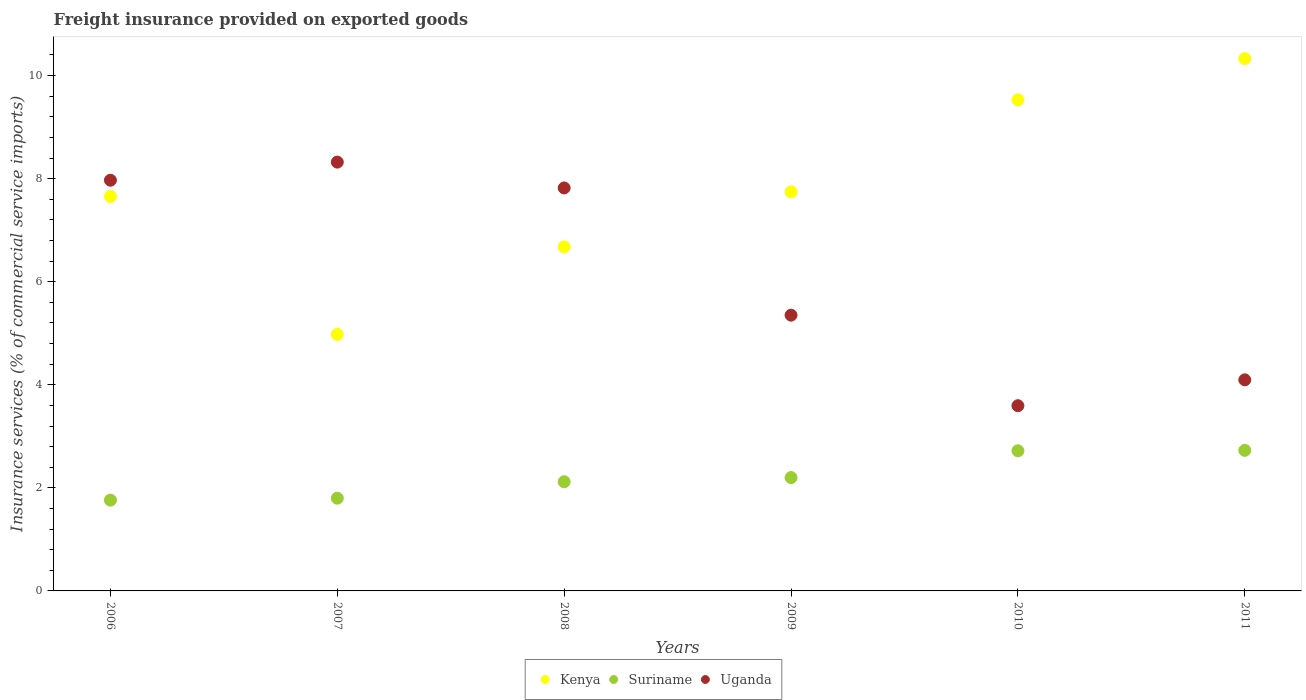What is the freight insurance provided on exported goods in Suriname in 2009?
Provide a short and direct response. 2.2. Across all years, what is the maximum freight insurance provided on exported goods in Uganda?
Keep it short and to the point. 8.32. Across all years, what is the minimum freight insurance provided on exported goods in Uganda?
Your answer should be very brief. 3.59. In which year was the freight insurance provided on exported goods in Kenya maximum?
Offer a terse response. 2011. In which year was the freight insurance provided on exported goods in Kenya minimum?
Make the answer very short. 2007. What is the total freight insurance provided on exported goods in Uganda in the graph?
Offer a very short reply. 37.15. What is the difference between the freight insurance provided on exported goods in Uganda in 2008 and that in 2011?
Keep it short and to the point. 3.72. What is the difference between the freight insurance provided on exported goods in Kenya in 2009 and the freight insurance provided on exported goods in Uganda in 2010?
Your answer should be compact. 4.15. What is the average freight insurance provided on exported goods in Suriname per year?
Your answer should be very brief. 2.22. In the year 2011, what is the difference between the freight insurance provided on exported goods in Kenya and freight insurance provided on exported goods in Suriname?
Provide a succinct answer. 7.6. In how many years, is the freight insurance provided on exported goods in Kenya greater than 3.2 %?
Provide a short and direct response. 6. What is the ratio of the freight insurance provided on exported goods in Uganda in 2006 to that in 2007?
Offer a very short reply. 0.96. Is the difference between the freight insurance provided on exported goods in Kenya in 2007 and 2011 greater than the difference between the freight insurance provided on exported goods in Suriname in 2007 and 2011?
Offer a very short reply. No. What is the difference between the highest and the second highest freight insurance provided on exported goods in Suriname?
Your answer should be very brief. 0.01. What is the difference between the highest and the lowest freight insurance provided on exported goods in Kenya?
Your answer should be compact. 5.35. Does the freight insurance provided on exported goods in Kenya monotonically increase over the years?
Offer a terse response. No. Is the freight insurance provided on exported goods in Kenya strictly greater than the freight insurance provided on exported goods in Uganda over the years?
Your answer should be compact. No. How many dotlines are there?
Your response must be concise. 3. How many years are there in the graph?
Ensure brevity in your answer.  6. Does the graph contain any zero values?
Your response must be concise. No. Does the graph contain grids?
Keep it short and to the point. No. Where does the legend appear in the graph?
Provide a succinct answer. Bottom center. How many legend labels are there?
Give a very brief answer. 3. What is the title of the graph?
Keep it short and to the point. Freight insurance provided on exported goods. What is the label or title of the X-axis?
Offer a very short reply. Years. What is the label or title of the Y-axis?
Keep it short and to the point. Insurance services (% of commercial service imports). What is the Insurance services (% of commercial service imports) in Kenya in 2006?
Provide a short and direct response. 7.65. What is the Insurance services (% of commercial service imports) of Suriname in 2006?
Provide a short and direct response. 1.76. What is the Insurance services (% of commercial service imports) of Uganda in 2006?
Your answer should be very brief. 7.97. What is the Insurance services (% of commercial service imports) of Kenya in 2007?
Offer a very short reply. 4.98. What is the Insurance services (% of commercial service imports) in Suriname in 2007?
Provide a short and direct response. 1.8. What is the Insurance services (% of commercial service imports) of Uganda in 2007?
Ensure brevity in your answer.  8.32. What is the Insurance services (% of commercial service imports) of Kenya in 2008?
Offer a terse response. 6.68. What is the Insurance services (% of commercial service imports) in Suriname in 2008?
Offer a very short reply. 2.12. What is the Insurance services (% of commercial service imports) of Uganda in 2008?
Give a very brief answer. 7.82. What is the Insurance services (% of commercial service imports) of Kenya in 2009?
Offer a very short reply. 7.74. What is the Insurance services (% of commercial service imports) in Suriname in 2009?
Your answer should be very brief. 2.2. What is the Insurance services (% of commercial service imports) of Uganda in 2009?
Ensure brevity in your answer.  5.35. What is the Insurance services (% of commercial service imports) in Kenya in 2010?
Provide a short and direct response. 9.53. What is the Insurance services (% of commercial service imports) in Suriname in 2010?
Your answer should be very brief. 2.72. What is the Insurance services (% of commercial service imports) in Uganda in 2010?
Provide a succinct answer. 3.59. What is the Insurance services (% of commercial service imports) of Kenya in 2011?
Your answer should be very brief. 10.33. What is the Insurance services (% of commercial service imports) of Suriname in 2011?
Keep it short and to the point. 2.73. What is the Insurance services (% of commercial service imports) in Uganda in 2011?
Offer a terse response. 4.1. Across all years, what is the maximum Insurance services (% of commercial service imports) of Kenya?
Offer a very short reply. 10.33. Across all years, what is the maximum Insurance services (% of commercial service imports) of Suriname?
Give a very brief answer. 2.73. Across all years, what is the maximum Insurance services (% of commercial service imports) in Uganda?
Provide a succinct answer. 8.32. Across all years, what is the minimum Insurance services (% of commercial service imports) in Kenya?
Ensure brevity in your answer.  4.98. Across all years, what is the minimum Insurance services (% of commercial service imports) of Suriname?
Give a very brief answer. 1.76. Across all years, what is the minimum Insurance services (% of commercial service imports) in Uganda?
Your response must be concise. 3.59. What is the total Insurance services (% of commercial service imports) in Kenya in the graph?
Your response must be concise. 46.91. What is the total Insurance services (% of commercial service imports) of Suriname in the graph?
Offer a very short reply. 13.33. What is the total Insurance services (% of commercial service imports) of Uganda in the graph?
Provide a succinct answer. 37.15. What is the difference between the Insurance services (% of commercial service imports) of Kenya in 2006 and that in 2007?
Provide a succinct answer. 2.68. What is the difference between the Insurance services (% of commercial service imports) of Suriname in 2006 and that in 2007?
Your answer should be very brief. -0.04. What is the difference between the Insurance services (% of commercial service imports) in Uganda in 2006 and that in 2007?
Ensure brevity in your answer.  -0.35. What is the difference between the Insurance services (% of commercial service imports) in Kenya in 2006 and that in 2008?
Keep it short and to the point. 0.98. What is the difference between the Insurance services (% of commercial service imports) in Suriname in 2006 and that in 2008?
Provide a succinct answer. -0.36. What is the difference between the Insurance services (% of commercial service imports) in Uganda in 2006 and that in 2008?
Make the answer very short. 0.15. What is the difference between the Insurance services (% of commercial service imports) in Kenya in 2006 and that in 2009?
Keep it short and to the point. -0.09. What is the difference between the Insurance services (% of commercial service imports) in Suriname in 2006 and that in 2009?
Make the answer very short. -0.44. What is the difference between the Insurance services (% of commercial service imports) of Uganda in 2006 and that in 2009?
Your response must be concise. 2.62. What is the difference between the Insurance services (% of commercial service imports) in Kenya in 2006 and that in 2010?
Make the answer very short. -1.88. What is the difference between the Insurance services (% of commercial service imports) in Suriname in 2006 and that in 2010?
Give a very brief answer. -0.96. What is the difference between the Insurance services (% of commercial service imports) of Uganda in 2006 and that in 2010?
Provide a short and direct response. 4.38. What is the difference between the Insurance services (% of commercial service imports) of Kenya in 2006 and that in 2011?
Make the answer very short. -2.67. What is the difference between the Insurance services (% of commercial service imports) in Suriname in 2006 and that in 2011?
Keep it short and to the point. -0.97. What is the difference between the Insurance services (% of commercial service imports) of Uganda in 2006 and that in 2011?
Your response must be concise. 3.87. What is the difference between the Insurance services (% of commercial service imports) of Kenya in 2007 and that in 2008?
Make the answer very short. -1.7. What is the difference between the Insurance services (% of commercial service imports) of Suriname in 2007 and that in 2008?
Keep it short and to the point. -0.32. What is the difference between the Insurance services (% of commercial service imports) in Uganda in 2007 and that in 2008?
Offer a terse response. 0.5. What is the difference between the Insurance services (% of commercial service imports) in Kenya in 2007 and that in 2009?
Make the answer very short. -2.77. What is the difference between the Insurance services (% of commercial service imports) in Suriname in 2007 and that in 2009?
Provide a succinct answer. -0.4. What is the difference between the Insurance services (% of commercial service imports) of Uganda in 2007 and that in 2009?
Provide a short and direct response. 2.97. What is the difference between the Insurance services (% of commercial service imports) of Kenya in 2007 and that in 2010?
Provide a succinct answer. -4.55. What is the difference between the Insurance services (% of commercial service imports) of Suriname in 2007 and that in 2010?
Give a very brief answer. -0.92. What is the difference between the Insurance services (% of commercial service imports) of Uganda in 2007 and that in 2010?
Provide a succinct answer. 4.73. What is the difference between the Insurance services (% of commercial service imports) in Kenya in 2007 and that in 2011?
Your response must be concise. -5.35. What is the difference between the Insurance services (% of commercial service imports) in Suriname in 2007 and that in 2011?
Give a very brief answer. -0.93. What is the difference between the Insurance services (% of commercial service imports) of Uganda in 2007 and that in 2011?
Make the answer very short. 4.22. What is the difference between the Insurance services (% of commercial service imports) in Kenya in 2008 and that in 2009?
Offer a terse response. -1.07. What is the difference between the Insurance services (% of commercial service imports) in Suriname in 2008 and that in 2009?
Provide a short and direct response. -0.08. What is the difference between the Insurance services (% of commercial service imports) in Uganda in 2008 and that in 2009?
Offer a terse response. 2.47. What is the difference between the Insurance services (% of commercial service imports) of Kenya in 2008 and that in 2010?
Provide a succinct answer. -2.85. What is the difference between the Insurance services (% of commercial service imports) of Suriname in 2008 and that in 2010?
Your response must be concise. -0.6. What is the difference between the Insurance services (% of commercial service imports) in Uganda in 2008 and that in 2010?
Provide a succinct answer. 4.23. What is the difference between the Insurance services (% of commercial service imports) of Kenya in 2008 and that in 2011?
Offer a terse response. -3.65. What is the difference between the Insurance services (% of commercial service imports) in Suriname in 2008 and that in 2011?
Provide a short and direct response. -0.61. What is the difference between the Insurance services (% of commercial service imports) of Uganda in 2008 and that in 2011?
Your answer should be compact. 3.72. What is the difference between the Insurance services (% of commercial service imports) in Kenya in 2009 and that in 2010?
Your answer should be very brief. -1.79. What is the difference between the Insurance services (% of commercial service imports) of Suriname in 2009 and that in 2010?
Give a very brief answer. -0.52. What is the difference between the Insurance services (% of commercial service imports) of Uganda in 2009 and that in 2010?
Your answer should be very brief. 1.76. What is the difference between the Insurance services (% of commercial service imports) in Kenya in 2009 and that in 2011?
Provide a succinct answer. -2.58. What is the difference between the Insurance services (% of commercial service imports) in Suriname in 2009 and that in 2011?
Provide a succinct answer. -0.53. What is the difference between the Insurance services (% of commercial service imports) in Uganda in 2009 and that in 2011?
Provide a short and direct response. 1.25. What is the difference between the Insurance services (% of commercial service imports) of Kenya in 2010 and that in 2011?
Provide a succinct answer. -0.8. What is the difference between the Insurance services (% of commercial service imports) in Suriname in 2010 and that in 2011?
Give a very brief answer. -0.01. What is the difference between the Insurance services (% of commercial service imports) of Uganda in 2010 and that in 2011?
Ensure brevity in your answer.  -0.5. What is the difference between the Insurance services (% of commercial service imports) in Kenya in 2006 and the Insurance services (% of commercial service imports) in Suriname in 2007?
Offer a very short reply. 5.85. What is the difference between the Insurance services (% of commercial service imports) of Kenya in 2006 and the Insurance services (% of commercial service imports) of Uganda in 2007?
Your answer should be very brief. -0.67. What is the difference between the Insurance services (% of commercial service imports) of Suriname in 2006 and the Insurance services (% of commercial service imports) of Uganda in 2007?
Provide a short and direct response. -6.56. What is the difference between the Insurance services (% of commercial service imports) in Kenya in 2006 and the Insurance services (% of commercial service imports) in Suriname in 2008?
Keep it short and to the point. 5.54. What is the difference between the Insurance services (% of commercial service imports) in Kenya in 2006 and the Insurance services (% of commercial service imports) in Uganda in 2008?
Your response must be concise. -0.17. What is the difference between the Insurance services (% of commercial service imports) in Suriname in 2006 and the Insurance services (% of commercial service imports) in Uganda in 2008?
Keep it short and to the point. -6.06. What is the difference between the Insurance services (% of commercial service imports) of Kenya in 2006 and the Insurance services (% of commercial service imports) of Suriname in 2009?
Your answer should be very brief. 5.45. What is the difference between the Insurance services (% of commercial service imports) in Kenya in 2006 and the Insurance services (% of commercial service imports) in Uganda in 2009?
Make the answer very short. 2.3. What is the difference between the Insurance services (% of commercial service imports) of Suriname in 2006 and the Insurance services (% of commercial service imports) of Uganda in 2009?
Ensure brevity in your answer.  -3.59. What is the difference between the Insurance services (% of commercial service imports) in Kenya in 2006 and the Insurance services (% of commercial service imports) in Suriname in 2010?
Your answer should be compact. 4.93. What is the difference between the Insurance services (% of commercial service imports) of Kenya in 2006 and the Insurance services (% of commercial service imports) of Uganda in 2010?
Make the answer very short. 4.06. What is the difference between the Insurance services (% of commercial service imports) of Suriname in 2006 and the Insurance services (% of commercial service imports) of Uganda in 2010?
Provide a succinct answer. -1.83. What is the difference between the Insurance services (% of commercial service imports) in Kenya in 2006 and the Insurance services (% of commercial service imports) in Suriname in 2011?
Offer a very short reply. 4.93. What is the difference between the Insurance services (% of commercial service imports) of Kenya in 2006 and the Insurance services (% of commercial service imports) of Uganda in 2011?
Your answer should be very brief. 3.56. What is the difference between the Insurance services (% of commercial service imports) of Suriname in 2006 and the Insurance services (% of commercial service imports) of Uganda in 2011?
Provide a succinct answer. -2.33. What is the difference between the Insurance services (% of commercial service imports) in Kenya in 2007 and the Insurance services (% of commercial service imports) in Suriname in 2008?
Provide a succinct answer. 2.86. What is the difference between the Insurance services (% of commercial service imports) of Kenya in 2007 and the Insurance services (% of commercial service imports) of Uganda in 2008?
Make the answer very short. -2.84. What is the difference between the Insurance services (% of commercial service imports) of Suriname in 2007 and the Insurance services (% of commercial service imports) of Uganda in 2008?
Keep it short and to the point. -6.02. What is the difference between the Insurance services (% of commercial service imports) of Kenya in 2007 and the Insurance services (% of commercial service imports) of Suriname in 2009?
Provide a short and direct response. 2.78. What is the difference between the Insurance services (% of commercial service imports) of Kenya in 2007 and the Insurance services (% of commercial service imports) of Uganda in 2009?
Offer a very short reply. -0.37. What is the difference between the Insurance services (% of commercial service imports) in Suriname in 2007 and the Insurance services (% of commercial service imports) in Uganda in 2009?
Keep it short and to the point. -3.55. What is the difference between the Insurance services (% of commercial service imports) of Kenya in 2007 and the Insurance services (% of commercial service imports) of Suriname in 2010?
Give a very brief answer. 2.26. What is the difference between the Insurance services (% of commercial service imports) in Kenya in 2007 and the Insurance services (% of commercial service imports) in Uganda in 2010?
Ensure brevity in your answer.  1.38. What is the difference between the Insurance services (% of commercial service imports) of Suriname in 2007 and the Insurance services (% of commercial service imports) of Uganda in 2010?
Your answer should be compact. -1.79. What is the difference between the Insurance services (% of commercial service imports) in Kenya in 2007 and the Insurance services (% of commercial service imports) in Suriname in 2011?
Your response must be concise. 2.25. What is the difference between the Insurance services (% of commercial service imports) in Kenya in 2007 and the Insurance services (% of commercial service imports) in Uganda in 2011?
Ensure brevity in your answer.  0.88. What is the difference between the Insurance services (% of commercial service imports) in Suriname in 2007 and the Insurance services (% of commercial service imports) in Uganda in 2011?
Ensure brevity in your answer.  -2.3. What is the difference between the Insurance services (% of commercial service imports) in Kenya in 2008 and the Insurance services (% of commercial service imports) in Suriname in 2009?
Ensure brevity in your answer.  4.48. What is the difference between the Insurance services (% of commercial service imports) in Kenya in 2008 and the Insurance services (% of commercial service imports) in Uganda in 2009?
Your response must be concise. 1.32. What is the difference between the Insurance services (% of commercial service imports) in Suriname in 2008 and the Insurance services (% of commercial service imports) in Uganda in 2009?
Provide a short and direct response. -3.23. What is the difference between the Insurance services (% of commercial service imports) in Kenya in 2008 and the Insurance services (% of commercial service imports) in Suriname in 2010?
Your answer should be very brief. 3.96. What is the difference between the Insurance services (% of commercial service imports) in Kenya in 2008 and the Insurance services (% of commercial service imports) in Uganda in 2010?
Your answer should be compact. 3.08. What is the difference between the Insurance services (% of commercial service imports) of Suriname in 2008 and the Insurance services (% of commercial service imports) of Uganda in 2010?
Your answer should be compact. -1.48. What is the difference between the Insurance services (% of commercial service imports) in Kenya in 2008 and the Insurance services (% of commercial service imports) in Suriname in 2011?
Your answer should be very brief. 3.95. What is the difference between the Insurance services (% of commercial service imports) in Kenya in 2008 and the Insurance services (% of commercial service imports) in Uganda in 2011?
Your answer should be very brief. 2.58. What is the difference between the Insurance services (% of commercial service imports) in Suriname in 2008 and the Insurance services (% of commercial service imports) in Uganda in 2011?
Your answer should be very brief. -1.98. What is the difference between the Insurance services (% of commercial service imports) of Kenya in 2009 and the Insurance services (% of commercial service imports) of Suriname in 2010?
Provide a succinct answer. 5.02. What is the difference between the Insurance services (% of commercial service imports) in Kenya in 2009 and the Insurance services (% of commercial service imports) in Uganda in 2010?
Your answer should be compact. 4.15. What is the difference between the Insurance services (% of commercial service imports) of Suriname in 2009 and the Insurance services (% of commercial service imports) of Uganda in 2010?
Your response must be concise. -1.39. What is the difference between the Insurance services (% of commercial service imports) in Kenya in 2009 and the Insurance services (% of commercial service imports) in Suriname in 2011?
Offer a terse response. 5.02. What is the difference between the Insurance services (% of commercial service imports) in Kenya in 2009 and the Insurance services (% of commercial service imports) in Uganda in 2011?
Provide a succinct answer. 3.65. What is the difference between the Insurance services (% of commercial service imports) in Suriname in 2009 and the Insurance services (% of commercial service imports) in Uganda in 2011?
Your response must be concise. -1.9. What is the difference between the Insurance services (% of commercial service imports) in Kenya in 2010 and the Insurance services (% of commercial service imports) in Suriname in 2011?
Your response must be concise. 6.8. What is the difference between the Insurance services (% of commercial service imports) in Kenya in 2010 and the Insurance services (% of commercial service imports) in Uganda in 2011?
Give a very brief answer. 5.43. What is the difference between the Insurance services (% of commercial service imports) of Suriname in 2010 and the Insurance services (% of commercial service imports) of Uganda in 2011?
Give a very brief answer. -1.38. What is the average Insurance services (% of commercial service imports) of Kenya per year?
Your response must be concise. 7.82. What is the average Insurance services (% of commercial service imports) of Suriname per year?
Give a very brief answer. 2.22. What is the average Insurance services (% of commercial service imports) of Uganda per year?
Your answer should be compact. 6.19. In the year 2006, what is the difference between the Insurance services (% of commercial service imports) of Kenya and Insurance services (% of commercial service imports) of Suriname?
Offer a terse response. 5.89. In the year 2006, what is the difference between the Insurance services (% of commercial service imports) of Kenya and Insurance services (% of commercial service imports) of Uganda?
Provide a short and direct response. -0.32. In the year 2006, what is the difference between the Insurance services (% of commercial service imports) of Suriname and Insurance services (% of commercial service imports) of Uganda?
Give a very brief answer. -6.21. In the year 2007, what is the difference between the Insurance services (% of commercial service imports) in Kenya and Insurance services (% of commercial service imports) in Suriname?
Make the answer very short. 3.18. In the year 2007, what is the difference between the Insurance services (% of commercial service imports) in Kenya and Insurance services (% of commercial service imports) in Uganda?
Give a very brief answer. -3.34. In the year 2007, what is the difference between the Insurance services (% of commercial service imports) of Suriname and Insurance services (% of commercial service imports) of Uganda?
Make the answer very short. -6.52. In the year 2008, what is the difference between the Insurance services (% of commercial service imports) in Kenya and Insurance services (% of commercial service imports) in Suriname?
Offer a very short reply. 4.56. In the year 2008, what is the difference between the Insurance services (% of commercial service imports) in Kenya and Insurance services (% of commercial service imports) in Uganda?
Ensure brevity in your answer.  -1.14. In the year 2008, what is the difference between the Insurance services (% of commercial service imports) in Suriname and Insurance services (% of commercial service imports) in Uganda?
Provide a short and direct response. -5.7. In the year 2009, what is the difference between the Insurance services (% of commercial service imports) of Kenya and Insurance services (% of commercial service imports) of Suriname?
Your answer should be very brief. 5.54. In the year 2009, what is the difference between the Insurance services (% of commercial service imports) in Kenya and Insurance services (% of commercial service imports) in Uganda?
Your answer should be very brief. 2.39. In the year 2009, what is the difference between the Insurance services (% of commercial service imports) of Suriname and Insurance services (% of commercial service imports) of Uganda?
Your answer should be very brief. -3.15. In the year 2010, what is the difference between the Insurance services (% of commercial service imports) in Kenya and Insurance services (% of commercial service imports) in Suriname?
Offer a very short reply. 6.81. In the year 2010, what is the difference between the Insurance services (% of commercial service imports) of Kenya and Insurance services (% of commercial service imports) of Uganda?
Offer a terse response. 5.93. In the year 2010, what is the difference between the Insurance services (% of commercial service imports) in Suriname and Insurance services (% of commercial service imports) in Uganda?
Offer a terse response. -0.87. In the year 2011, what is the difference between the Insurance services (% of commercial service imports) of Kenya and Insurance services (% of commercial service imports) of Suriname?
Offer a very short reply. 7.6. In the year 2011, what is the difference between the Insurance services (% of commercial service imports) of Kenya and Insurance services (% of commercial service imports) of Uganda?
Offer a terse response. 6.23. In the year 2011, what is the difference between the Insurance services (% of commercial service imports) in Suriname and Insurance services (% of commercial service imports) in Uganda?
Offer a very short reply. -1.37. What is the ratio of the Insurance services (% of commercial service imports) of Kenya in 2006 to that in 2007?
Provide a short and direct response. 1.54. What is the ratio of the Insurance services (% of commercial service imports) of Suriname in 2006 to that in 2007?
Provide a short and direct response. 0.98. What is the ratio of the Insurance services (% of commercial service imports) of Uganda in 2006 to that in 2007?
Your response must be concise. 0.96. What is the ratio of the Insurance services (% of commercial service imports) in Kenya in 2006 to that in 2008?
Offer a terse response. 1.15. What is the ratio of the Insurance services (% of commercial service imports) in Suriname in 2006 to that in 2008?
Make the answer very short. 0.83. What is the ratio of the Insurance services (% of commercial service imports) in Uganda in 2006 to that in 2008?
Provide a short and direct response. 1.02. What is the ratio of the Insurance services (% of commercial service imports) of Kenya in 2006 to that in 2009?
Provide a short and direct response. 0.99. What is the ratio of the Insurance services (% of commercial service imports) of Suriname in 2006 to that in 2009?
Provide a short and direct response. 0.8. What is the ratio of the Insurance services (% of commercial service imports) in Uganda in 2006 to that in 2009?
Ensure brevity in your answer.  1.49. What is the ratio of the Insurance services (% of commercial service imports) in Kenya in 2006 to that in 2010?
Offer a very short reply. 0.8. What is the ratio of the Insurance services (% of commercial service imports) of Suriname in 2006 to that in 2010?
Your answer should be very brief. 0.65. What is the ratio of the Insurance services (% of commercial service imports) in Uganda in 2006 to that in 2010?
Provide a short and direct response. 2.22. What is the ratio of the Insurance services (% of commercial service imports) in Kenya in 2006 to that in 2011?
Offer a terse response. 0.74. What is the ratio of the Insurance services (% of commercial service imports) in Suriname in 2006 to that in 2011?
Provide a short and direct response. 0.65. What is the ratio of the Insurance services (% of commercial service imports) of Uganda in 2006 to that in 2011?
Provide a short and direct response. 1.95. What is the ratio of the Insurance services (% of commercial service imports) of Kenya in 2007 to that in 2008?
Your response must be concise. 0.75. What is the ratio of the Insurance services (% of commercial service imports) of Suriname in 2007 to that in 2008?
Make the answer very short. 0.85. What is the ratio of the Insurance services (% of commercial service imports) in Uganda in 2007 to that in 2008?
Make the answer very short. 1.06. What is the ratio of the Insurance services (% of commercial service imports) of Kenya in 2007 to that in 2009?
Ensure brevity in your answer.  0.64. What is the ratio of the Insurance services (% of commercial service imports) in Suriname in 2007 to that in 2009?
Give a very brief answer. 0.82. What is the ratio of the Insurance services (% of commercial service imports) of Uganda in 2007 to that in 2009?
Offer a very short reply. 1.55. What is the ratio of the Insurance services (% of commercial service imports) of Kenya in 2007 to that in 2010?
Provide a succinct answer. 0.52. What is the ratio of the Insurance services (% of commercial service imports) in Suriname in 2007 to that in 2010?
Offer a very short reply. 0.66. What is the ratio of the Insurance services (% of commercial service imports) of Uganda in 2007 to that in 2010?
Give a very brief answer. 2.32. What is the ratio of the Insurance services (% of commercial service imports) of Kenya in 2007 to that in 2011?
Give a very brief answer. 0.48. What is the ratio of the Insurance services (% of commercial service imports) in Suriname in 2007 to that in 2011?
Offer a terse response. 0.66. What is the ratio of the Insurance services (% of commercial service imports) of Uganda in 2007 to that in 2011?
Provide a short and direct response. 2.03. What is the ratio of the Insurance services (% of commercial service imports) in Kenya in 2008 to that in 2009?
Ensure brevity in your answer.  0.86. What is the ratio of the Insurance services (% of commercial service imports) in Suriname in 2008 to that in 2009?
Ensure brevity in your answer.  0.96. What is the ratio of the Insurance services (% of commercial service imports) in Uganda in 2008 to that in 2009?
Give a very brief answer. 1.46. What is the ratio of the Insurance services (% of commercial service imports) of Kenya in 2008 to that in 2010?
Your answer should be very brief. 0.7. What is the ratio of the Insurance services (% of commercial service imports) in Suriname in 2008 to that in 2010?
Your answer should be compact. 0.78. What is the ratio of the Insurance services (% of commercial service imports) of Uganda in 2008 to that in 2010?
Your response must be concise. 2.18. What is the ratio of the Insurance services (% of commercial service imports) in Kenya in 2008 to that in 2011?
Ensure brevity in your answer.  0.65. What is the ratio of the Insurance services (% of commercial service imports) in Suriname in 2008 to that in 2011?
Your answer should be compact. 0.78. What is the ratio of the Insurance services (% of commercial service imports) in Uganda in 2008 to that in 2011?
Your response must be concise. 1.91. What is the ratio of the Insurance services (% of commercial service imports) in Kenya in 2009 to that in 2010?
Provide a short and direct response. 0.81. What is the ratio of the Insurance services (% of commercial service imports) of Suriname in 2009 to that in 2010?
Make the answer very short. 0.81. What is the ratio of the Insurance services (% of commercial service imports) of Uganda in 2009 to that in 2010?
Offer a terse response. 1.49. What is the ratio of the Insurance services (% of commercial service imports) in Kenya in 2009 to that in 2011?
Make the answer very short. 0.75. What is the ratio of the Insurance services (% of commercial service imports) in Suriname in 2009 to that in 2011?
Offer a terse response. 0.81. What is the ratio of the Insurance services (% of commercial service imports) in Uganda in 2009 to that in 2011?
Your response must be concise. 1.31. What is the ratio of the Insurance services (% of commercial service imports) of Kenya in 2010 to that in 2011?
Offer a terse response. 0.92. What is the ratio of the Insurance services (% of commercial service imports) in Uganda in 2010 to that in 2011?
Make the answer very short. 0.88. What is the difference between the highest and the second highest Insurance services (% of commercial service imports) in Kenya?
Ensure brevity in your answer.  0.8. What is the difference between the highest and the second highest Insurance services (% of commercial service imports) of Suriname?
Keep it short and to the point. 0.01. What is the difference between the highest and the second highest Insurance services (% of commercial service imports) of Uganda?
Provide a short and direct response. 0.35. What is the difference between the highest and the lowest Insurance services (% of commercial service imports) of Kenya?
Provide a succinct answer. 5.35. What is the difference between the highest and the lowest Insurance services (% of commercial service imports) of Suriname?
Your answer should be very brief. 0.97. What is the difference between the highest and the lowest Insurance services (% of commercial service imports) of Uganda?
Keep it short and to the point. 4.73. 